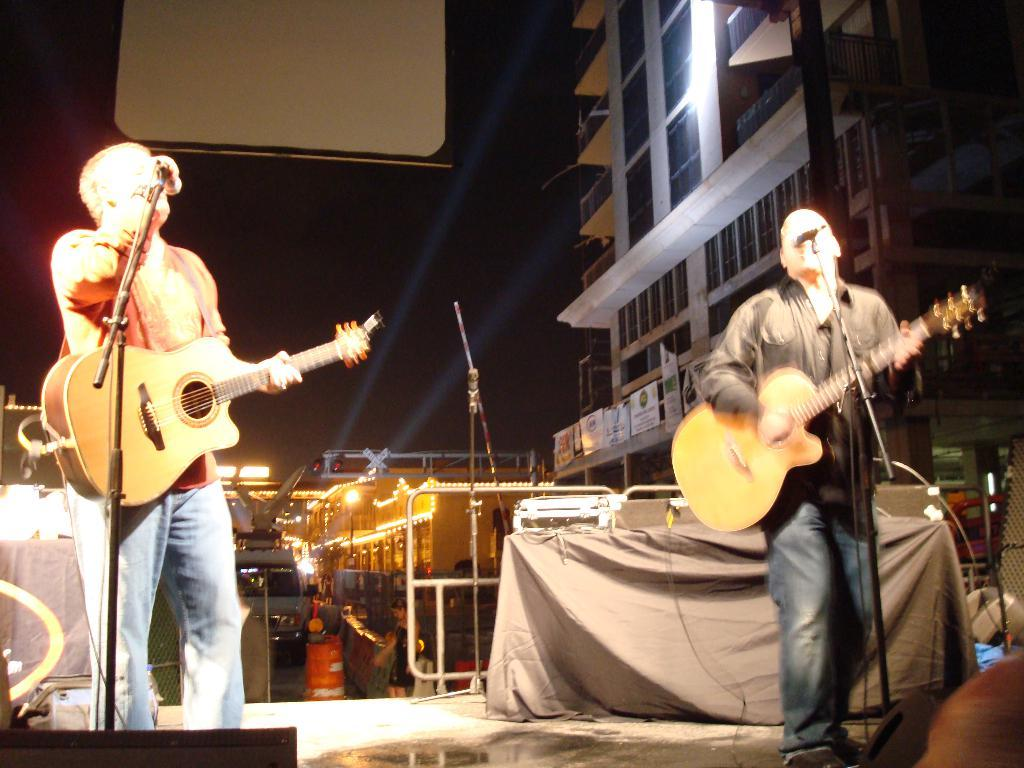How many people are on the platform in the image? There are two persons standing on the platform in the image. What are the two persons doing? One person is singing, and the other person is playing a guitar. What is in front of the two persons? There is a microphone (mike) in front of the two persons. What can be seen in the background of the image? There is a huge building visible in the background. What is the lighting like in the image? There are lights present in the image. What type of approval does the boy in the image need to continue singing? There is no boy present in the image, and therefore no approval is needed for singing. 